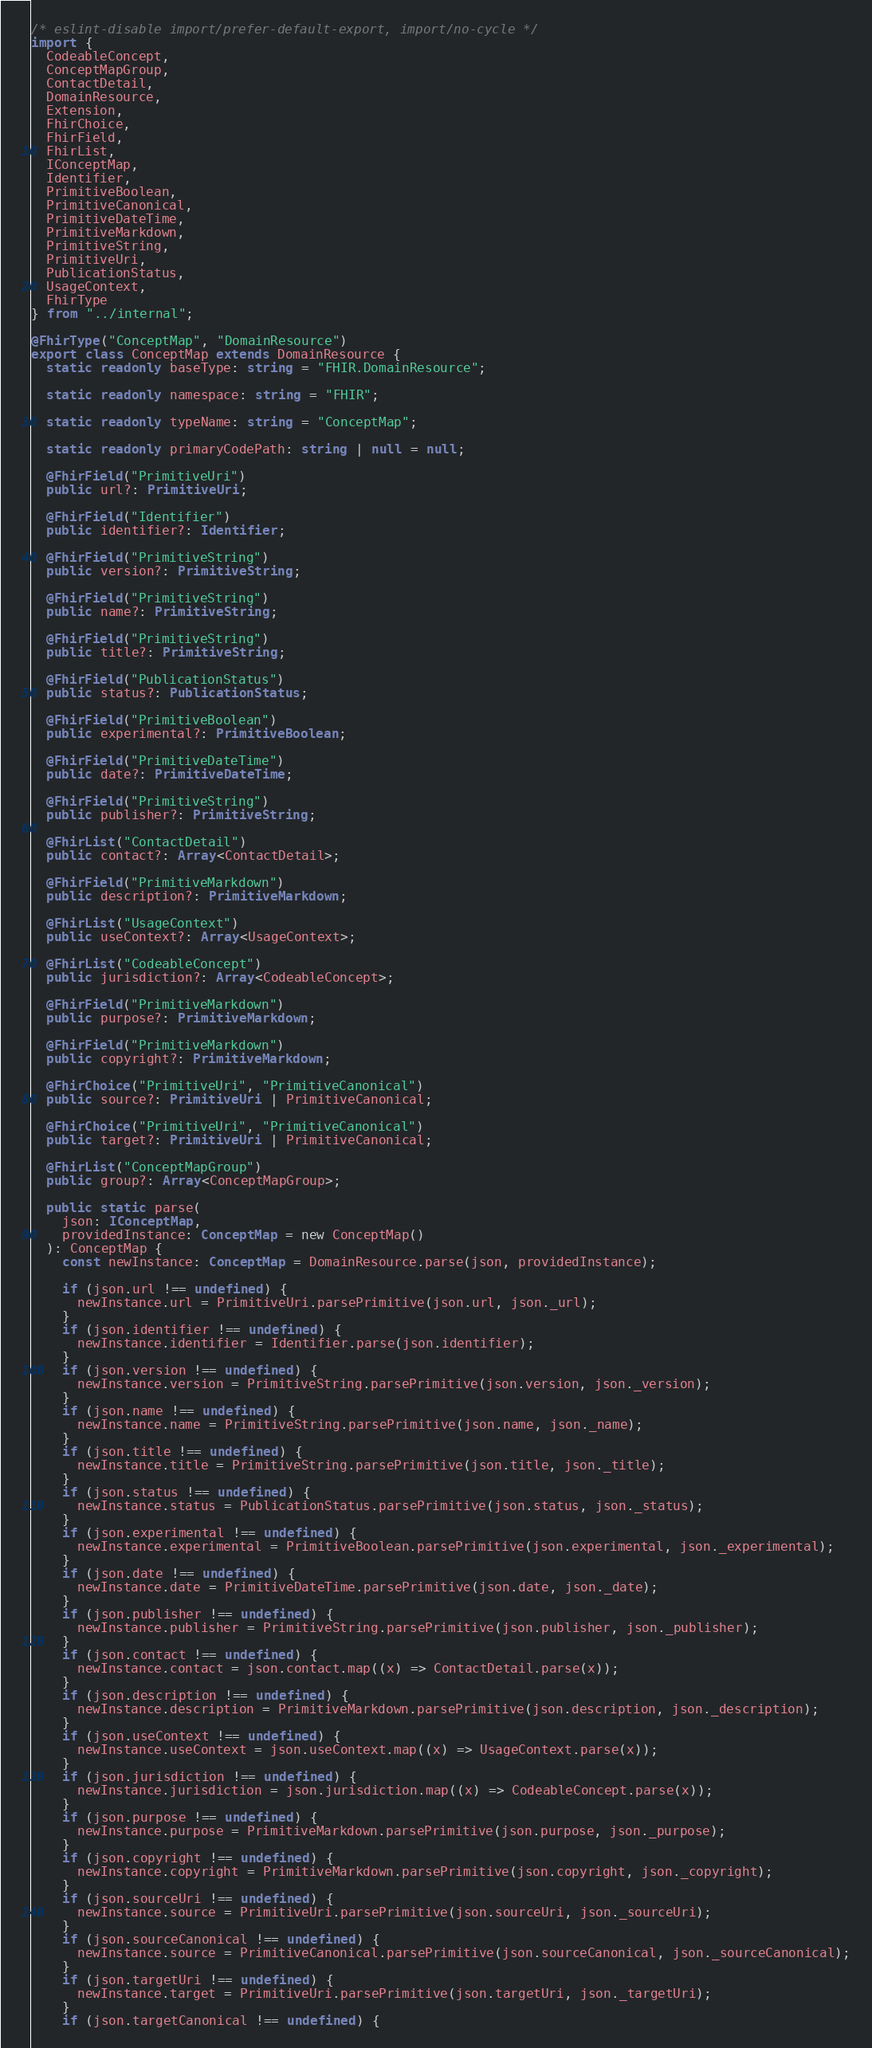<code> <loc_0><loc_0><loc_500><loc_500><_TypeScript_>/* eslint-disable import/prefer-default-export, import/no-cycle */
import {
  CodeableConcept,
  ConceptMapGroup,
  ContactDetail,
  DomainResource,
  Extension,
  FhirChoice,
  FhirField,
  FhirList,
  IConceptMap,
  Identifier,
  PrimitiveBoolean,
  PrimitiveCanonical,
  PrimitiveDateTime,
  PrimitiveMarkdown,
  PrimitiveString,
  PrimitiveUri,
  PublicationStatus,
  UsageContext,
  FhirType
} from "../internal";

@FhirType("ConceptMap", "DomainResource")
export class ConceptMap extends DomainResource {
  static readonly baseType: string = "FHIR.DomainResource";

  static readonly namespace: string = "FHIR";

  static readonly typeName: string = "ConceptMap";

  static readonly primaryCodePath: string | null = null;

  @FhirField("PrimitiveUri")
  public url?: PrimitiveUri;

  @FhirField("Identifier")
  public identifier?: Identifier;

  @FhirField("PrimitiveString")
  public version?: PrimitiveString;

  @FhirField("PrimitiveString")
  public name?: PrimitiveString;

  @FhirField("PrimitiveString")
  public title?: PrimitiveString;

  @FhirField("PublicationStatus")
  public status?: PublicationStatus;

  @FhirField("PrimitiveBoolean")
  public experimental?: PrimitiveBoolean;

  @FhirField("PrimitiveDateTime")
  public date?: PrimitiveDateTime;

  @FhirField("PrimitiveString")
  public publisher?: PrimitiveString;

  @FhirList("ContactDetail")
  public contact?: Array<ContactDetail>;

  @FhirField("PrimitiveMarkdown")
  public description?: PrimitiveMarkdown;

  @FhirList("UsageContext")
  public useContext?: Array<UsageContext>;

  @FhirList("CodeableConcept")
  public jurisdiction?: Array<CodeableConcept>;

  @FhirField("PrimitiveMarkdown")
  public purpose?: PrimitiveMarkdown;

  @FhirField("PrimitiveMarkdown")
  public copyright?: PrimitiveMarkdown;

  @FhirChoice("PrimitiveUri", "PrimitiveCanonical")
  public source?: PrimitiveUri | PrimitiveCanonical;

  @FhirChoice("PrimitiveUri", "PrimitiveCanonical")
  public target?: PrimitiveUri | PrimitiveCanonical;

  @FhirList("ConceptMapGroup")
  public group?: Array<ConceptMapGroup>;

  public static parse(
    json: IConceptMap,
    providedInstance: ConceptMap = new ConceptMap()
  ): ConceptMap {
    const newInstance: ConceptMap = DomainResource.parse(json, providedInstance);
  
    if (json.url !== undefined) {
      newInstance.url = PrimitiveUri.parsePrimitive(json.url, json._url);
    }
    if (json.identifier !== undefined) {
      newInstance.identifier = Identifier.parse(json.identifier);
    }
    if (json.version !== undefined) {
      newInstance.version = PrimitiveString.parsePrimitive(json.version, json._version);
    }
    if (json.name !== undefined) {
      newInstance.name = PrimitiveString.parsePrimitive(json.name, json._name);
    }
    if (json.title !== undefined) {
      newInstance.title = PrimitiveString.parsePrimitive(json.title, json._title);
    }
    if (json.status !== undefined) {
      newInstance.status = PublicationStatus.parsePrimitive(json.status, json._status);
    }
    if (json.experimental !== undefined) {
      newInstance.experimental = PrimitiveBoolean.parsePrimitive(json.experimental, json._experimental);
    }
    if (json.date !== undefined) {
      newInstance.date = PrimitiveDateTime.parsePrimitive(json.date, json._date);
    }
    if (json.publisher !== undefined) {
      newInstance.publisher = PrimitiveString.parsePrimitive(json.publisher, json._publisher);
    }
    if (json.contact !== undefined) {
      newInstance.contact = json.contact.map((x) => ContactDetail.parse(x));
    }
    if (json.description !== undefined) {
      newInstance.description = PrimitiveMarkdown.parsePrimitive(json.description, json._description);
    }
    if (json.useContext !== undefined) {
      newInstance.useContext = json.useContext.map((x) => UsageContext.parse(x));
    }
    if (json.jurisdiction !== undefined) {
      newInstance.jurisdiction = json.jurisdiction.map((x) => CodeableConcept.parse(x));
    }
    if (json.purpose !== undefined) {
      newInstance.purpose = PrimitiveMarkdown.parsePrimitive(json.purpose, json._purpose);
    }
    if (json.copyright !== undefined) {
      newInstance.copyright = PrimitiveMarkdown.parsePrimitive(json.copyright, json._copyright);
    }
    if (json.sourceUri !== undefined) {
      newInstance.source = PrimitiveUri.parsePrimitive(json.sourceUri, json._sourceUri);
    }
    if (json.sourceCanonical !== undefined) {
      newInstance.source = PrimitiveCanonical.parsePrimitive(json.sourceCanonical, json._sourceCanonical);
    }
    if (json.targetUri !== undefined) {
      newInstance.target = PrimitiveUri.parsePrimitive(json.targetUri, json._targetUri);
    }
    if (json.targetCanonical !== undefined) {</code> 